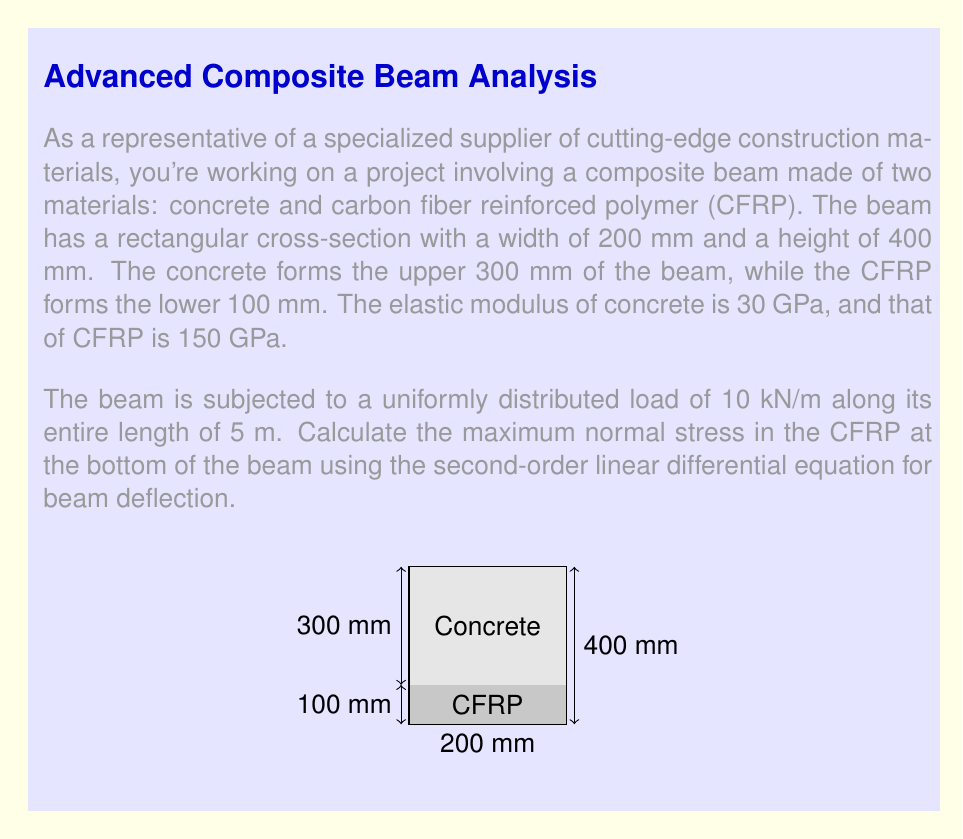Teach me how to tackle this problem. To solve this problem, we'll follow these steps:

1) First, we need to calculate the moment of inertia of the composite beam:

   For concrete: $I_c = \frac{1}{12} \cdot 200 \cdot 300^3 + 200 \cdot 300 \cdot 50^2 = 495 \cdot 10^6$ mm⁴
   For CFRP: $I_f = \frac{1}{12} \cdot 200 \cdot 100^3 + 200 \cdot 100 \cdot 150^2 = 455 \cdot 10^6$ mm⁴

   Total moment of inertia: $I = 495 \cdot 10^6 + 455 \cdot 10^6 = 950 \cdot 10^6$ mm⁴

2) Calculate the equivalent elastic modulus:

   $EI_{eq} = E_c I_c + E_f I_f = 30 \cdot 10^3 \cdot 495 \cdot 10^6 + 150 \cdot 10^3 \cdot 455 \cdot 10^6 = 83.25 \cdot 10^{12}$ N·mm²

3) The second-order linear differential equation for beam deflection is:

   $$EI \frac{d^2y}{dx^2} = M(x)$$

   Where $M(x)$ is the bending moment at any point x along the beam.

4) For a uniformly distributed load $w$, the maximum bending moment occurs at the center of the beam and is given by:

   $$M_{max} = \frac{wL^2}{8}$$

   Where $L$ is the length of the beam.

5) Calculate the maximum bending moment:

   $M_{max} = \frac{10 \cdot 5^2}{8} = 31.25$ kN·m = $31.25 \cdot 10^6$ N·mm

6) The maximum normal stress occurs at the bottom of the beam and is given by:

   $$\sigma_{max} = \frac{M_{max} \cdot y}{I_{eq}}$$

   Where $y$ is the distance from the neutral axis to the bottom of the beam (200 mm).

7) Calculate the maximum stress:

   $$\sigma_{max} = \frac{31.25 \cdot 10^6 \cdot 200}{950 \cdot 10^6} = 65.79 \text{ MPa}$$
Answer: $65.79 \text{ MPa}$ 